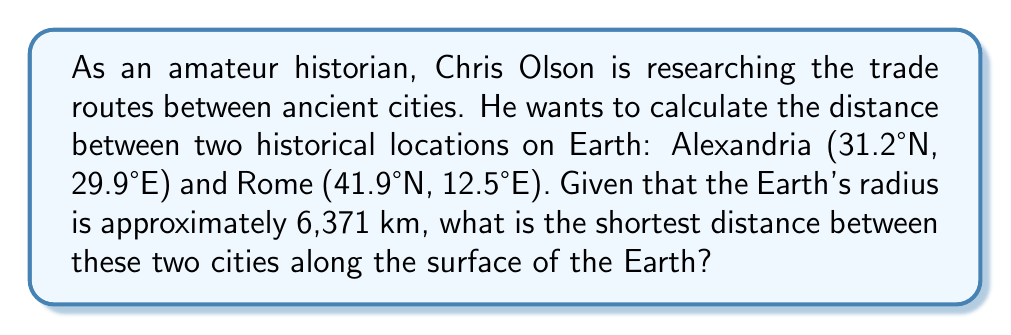Solve this math problem. To solve this problem, we'll use the Haversine formula, which calculates the great-circle distance between two points on a sphere given their longitudes and latitudes. Here's the step-by-step solution:

1. Convert the latitudes and longitudes from degrees to radians:
   $\phi_1 = 31.2° \times \frac{\pi}{180} = 0.5445$ rad (Alexandria latitude)
   $\lambda_1 = 29.9° \times \frac{\pi}{180} = 0.5218$ rad (Alexandria longitude)
   $\phi_2 = 41.9° \times \frac{\pi}{180} = 0.7313$ rad (Rome latitude)
   $\lambda_2 = 12.5° \times \frac{\pi}{180} = 0.2182$ rad (Rome longitude)

2. Calculate the difference in longitudes:
   $\Delta\lambda = \lambda_2 - \lambda_1 = 0.2182 - 0.5218 = -0.3036$ rad

3. Apply the Haversine formula:
   $$a = \sin^2\left(\frac{\phi_2 - \phi_1}{2}\right) + \cos(\phi_1) \cos(\phi_2) \sin^2\left(\frac{\Delta\lambda}{2}\right)$$

   $$c = 2 \times \arctan2(\sqrt{a}, \sqrt{1-a})$$

   $$d = R \times c$$

   where $R$ is the Earth's radius (6,371 km).

4. Calculate $a$:
   $$a = \sin^2\left(\frac{0.7313 - 0.5445}{2}\right) + \cos(0.5445) \cos(0.7313) \sin^2\left(\frac{-0.3036}{2}\right) = 0.0284$$

5. Calculate $c$:
   $$c = 2 \times \arctan2(\sqrt{0.0284}, \sqrt{1-0.0284}) = 0.3375$$

6. Calculate the distance $d$:
   $$d = 6371 \times 0.3375 = 2150.2 \text{ km}$$

Therefore, the shortest distance between Alexandria and Rome along the surface of the Earth is approximately 2150.2 km.
Answer: 2150.2 km 